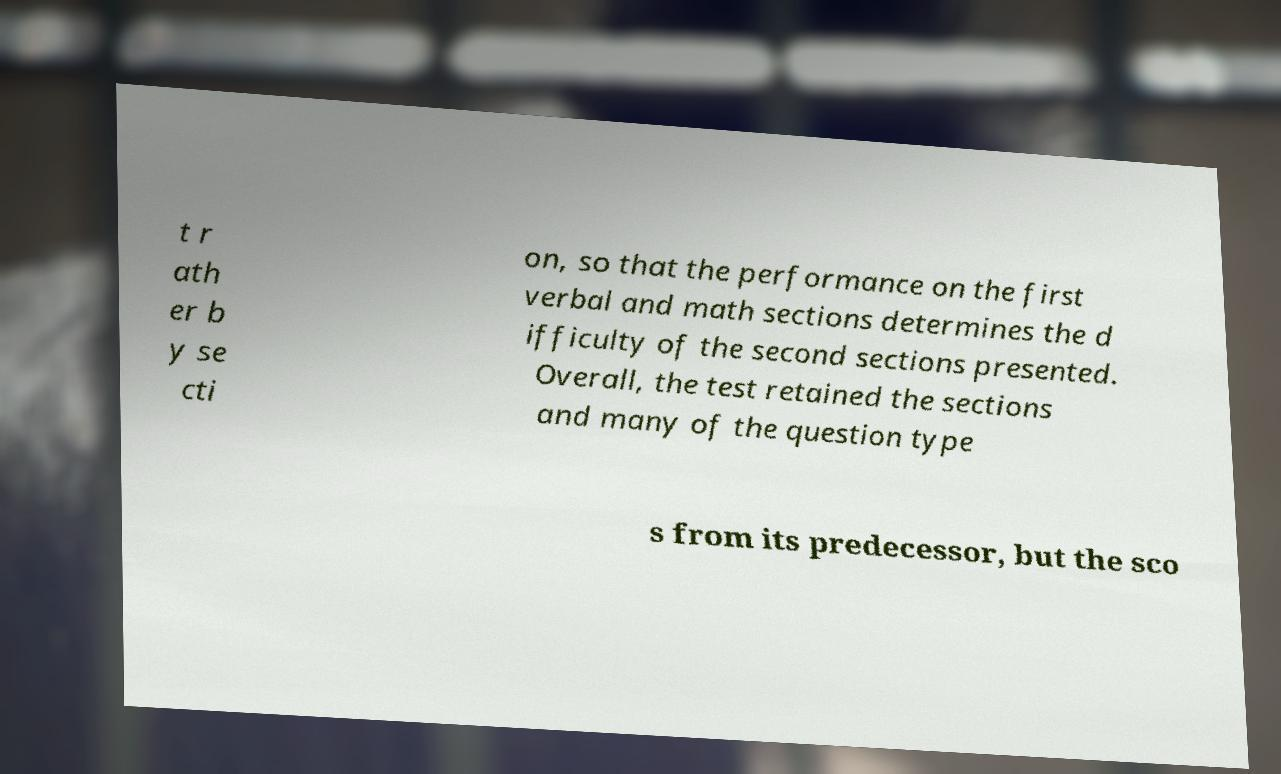Can you read and provide the text displayed in the image?This photo seems to have some interesting text. Can you extract and type it out for me? t r ath er b y se cti on, so that the performance on the first verbal and math sections determines the d ifficulty of the second sections presented. Overall, the test retained the sections and many of the question type s from its predecessor, but the sco 